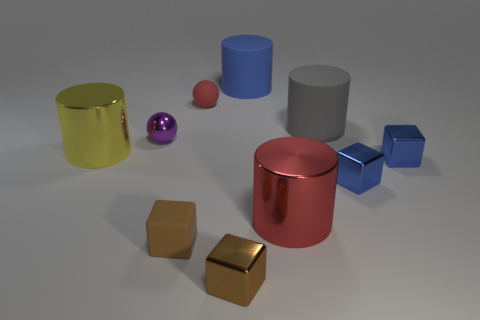What material is the cylinder that is the same color as the tiny rubber ball?
Your answer should be very brief. Metal. How many cylinders are either tiny purple things or large things?
Offer a very short reply. 4. Do the small sphere that is to the right of the brown matte cube and the big cylinder that is to the right of the big red thing have the same material?
Your answer should be compact. Yes. What shape is the yellow thing that is the same size as the gray matte object?
Ensure brevity in your answer.  Cylinder. What number of other objects are there of the same color as the rubber cube?
Make the answer very short. 1. What number of gray objects are spheres or big shiny spheres?
Your answer should be very brief. 0. There is a red object behind the big gray matte object; does it have the same shape as the brown thing left of the brown metal object?
Provide a succinct answer. No. How many other things are there of the same material as the big blue thing?
Your response must be concise. 3. Is there a large yellow cylinder in front of the small metallic object in front of the rubber thing in front of the small shiny ball?
Ensure brevity in your answer.  No. Are the large red cylinder and the large blue object made of the same material?
Your answer should be compact. No. 